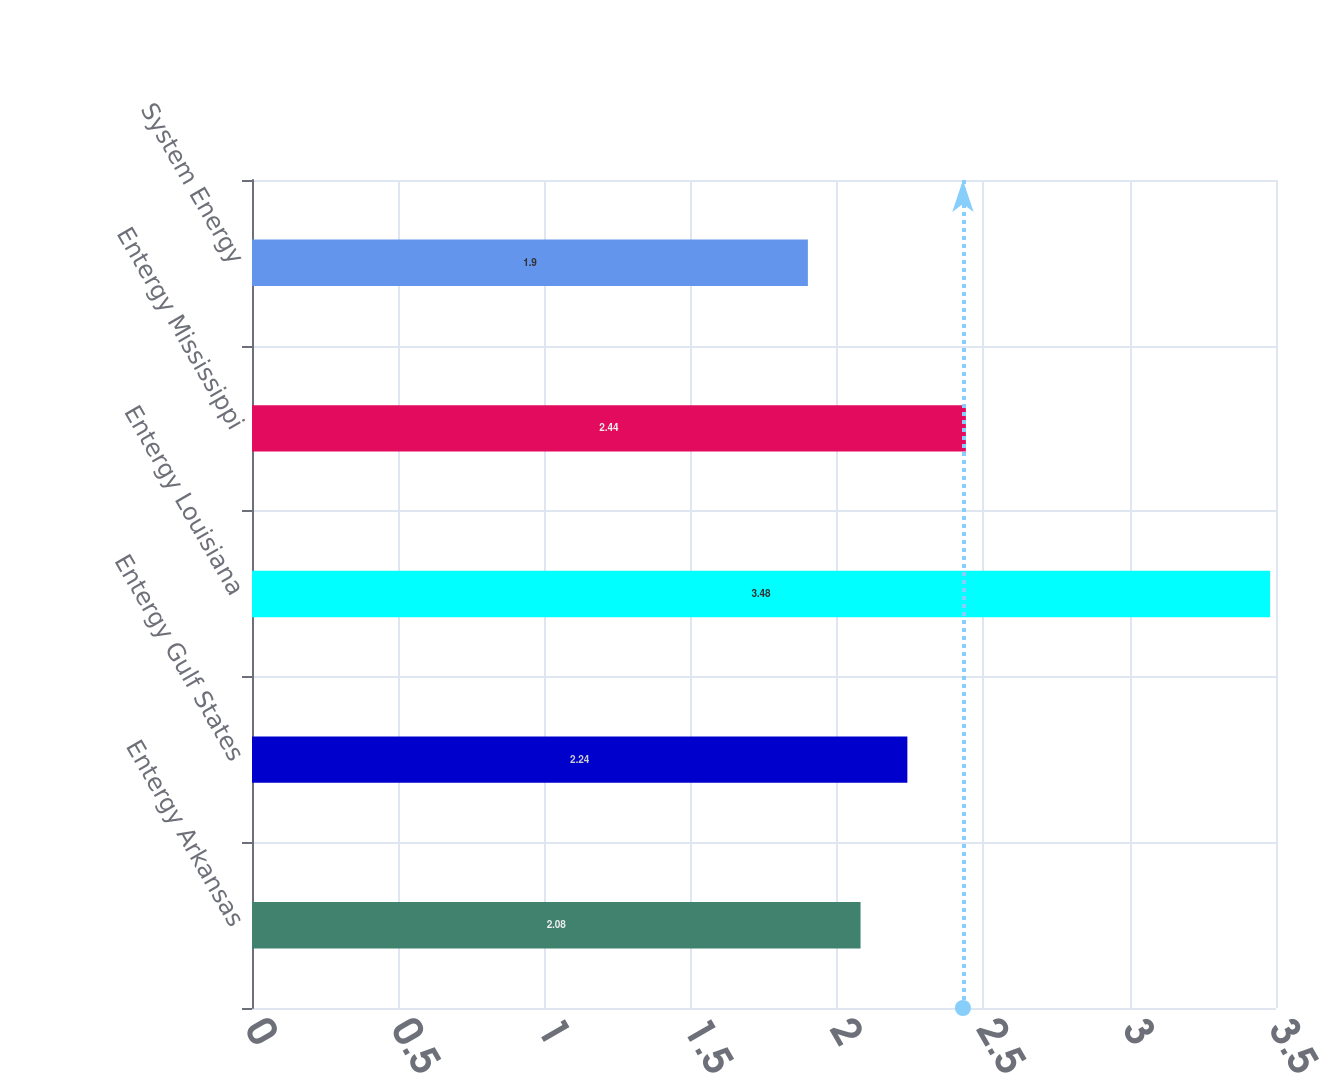Convert chart. <chart><loc_0><loc_0><loc_500><loc_500><bar_chart><fcel>Entergy Arkansas<fcel>Entergy Gulf States<fcel>Entergy Louisiana<fcel>Entergy Mississippi<fcel>System Energy<nl><fcel>2.08<fcel>2.24<fcel>3.48<fcel>2.44<fcel>1.9<nl></chart> 